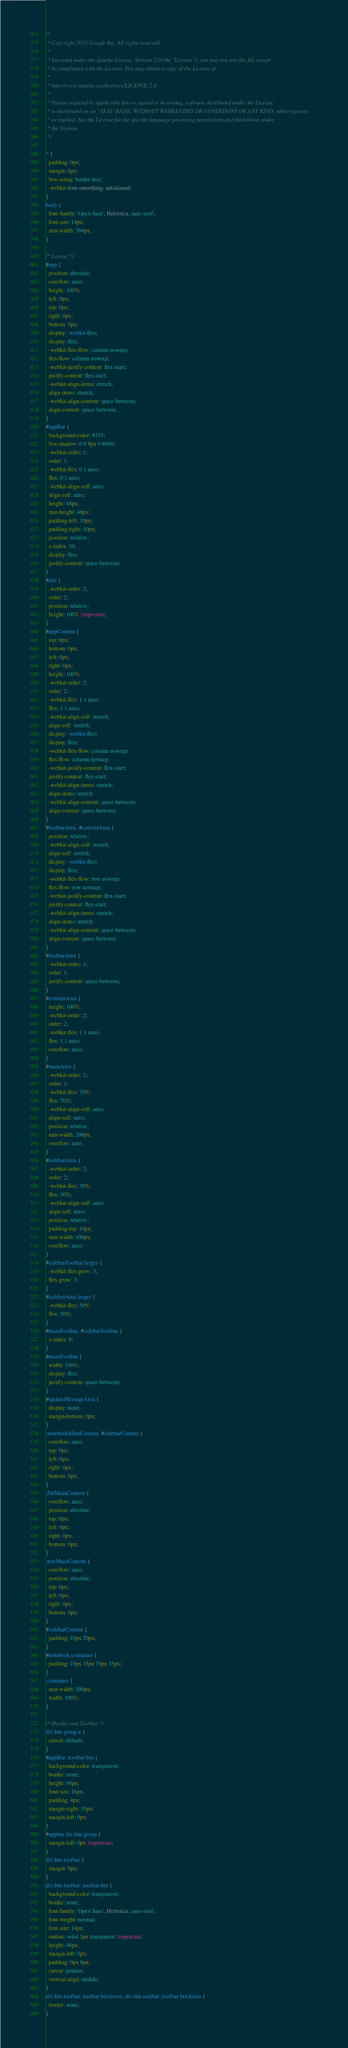<code> <loc_0><loc_0><loc_500><loc_500><_CSS_>/*
 * Copyright 2015 Google Inc. All rights reserved.
 *
 * Licensed under the Apache License, Version 2.0 (the "License"); you may not use this file except
 * in compliance with the License. You may obtain a copy of the License at
 *
 * http://www.apache.org/licenses/LICENSE-2.0
 *
 * Unless required by applicable law or agreed to in writing, software distributed under the License
 * is distributed on an "AS IS" BASIS, WITHOUT WARRANTIES OR CONDITIONS OF ANY KIND, either express
 * or implied. See the License for the specific language governing permissions and limitations under
 * the License.
 */

* {
  padding: 0px;
  margin: 0px;
  box-sizing: border-box;
  -webkit-font-smoothing: antialiased;
}
body {
  font-family: 'Open Sans', Helvetica, sans-serif;
  font-size: 14px;
  min-width: 760px;
}

/* Layout */
#app {
  position: absolute;
  overflow: auto;
  height: 100%;
  left: 0px;
  top: 0px;
  right: 0px;
  bottom: 0px;
  display: -webkit-flex;
  display: flex;
  -webkit-flex-flow: column nowrap;
  flex-flow: column nowrap;
  -webkit-justify-content: flex-start;
  justify-content: flex-start;
  -webkit-align-items: stretch;
  align-items: stretch;
  -webkit-align-content: space-between;
  align-content: space-between;
}
#appBar {
  background-color: #333;
  box-shadow: 0 0 8px 0 #000;
  -webkit-order: 1;
  order: 1;
  -webkit-flex: 0 1 auto;
  flex: 0 1 auto;
  -webkit-align-self: auto;
  align-self: auto;
  height: 48px;
  min-height: 48px;
  padding-left: 10px;
  padding-right: 10px;
  position: relative;
  z-index: 10;
  display: flex;
  justify-content: space-between;
}
#site {
  -webkit-order: 2;
  order: 2;
  position: relative;
  height: 100% !important;
}
#appContent {
  top: 0px;
  bottom: 0px;
  left: 0px;
  right: 0px;
  height: 100%;
  -webkit-order: 2;
  order: 2;
  -webkit-flex: 1 1 auto;
  flex: 1 1 auto;
  -webkit-align-self: stretch;
  align-self: stretch;
  display: -webkit-flex;
  display: flex;
  -webkit-flex-flow: column nowrap;
  flex-flow: column nowrap;
  -webkit-justify-content: flex-start;
  justify-content: flex-start;
  -webkit-align-items: stretch;
  align-items: stretch;
  -webkit-align-content: space-between;
  align-content: space-between;
}
#toolbarArea, #contentArea {
  position: relative;
  -webkit-align-self: stretch;
  align-self: stretch;
  display: -webkit-flex;
  display: flex;
  -webkit-flex-flow: row nowrap;
  flex-flow: row nowrap;
  -webkit-justify-content: flex-start;
  justify-content: flex-start;
  -webkit-align-items: stretch;
  align-items: stretch;
  -webkit-align-content: space-between;
  align-content: space-between;
}
#toolbarArea {
  -webkit-order: 1;
  order: 1;
  justify-content: space-between;
}
#contentArea {
  height: 100%;
  -webkit-order: 2;
  order: 2;
  -webkit-flex: 1 1 auto;
  flex: 1 1 auto;
  overflow: auto;
}
#mainArea {
  -webkit-order: 1;
  order: 1;
  -webkit-flex: 70%;
  flex: 70%;
  -webkit-align-self: auto;
  align-self: auto;
  position: relative;
  min-width: 200px;
  overflow: auto;
}
#sidebarArea {
  -webkit-order: 2;
  order: 2;
  -webkit-flex: 30%;
  flex: 30%;
  -webkit-align-self: auto;
  align-self: auto;
  position: relative;
  padding-top: 10px;
  min-width: 100px;
  overflow: auto;
}
#sidebarToolbar.larger {
  -webkit-flex-grow: 3;
  flex-grow: 3;
}
#sidebarArea.larger {
  -webkit-flex: 50%;
  flex: 50%;
}
#mainToolbar, #sidebarToolbar {
  z-index: 8;
}
#mainToolbar {
  width: 100%;
  display: flex;
  justify-content: space-between;
}
#updateMessageArea {
  display: none;
  margin-bottom: 0px;
}
.notebookMainContent, #sidebarContent {
  overflow: auto;
  top: 0px;
  left: 0px;
  right: 0px;
  bottom: 0px;
}
.fileMainContent {
  overflow: auto;
  position: absolute;
  top: 0px;
  left: 0px;
  right: 0px;
  bottom: 0px;
}
.treeMainContent {
  overflow: auto;
  position: absolute;
  top: 0px;
  left: 0px;
  right: 0px;
  bottom: 0px;
}
#sidebarContent {
  padding: 10px 20px;
}
#notebook-container {
  padding: 10px 35px 70px 35px;
}
.container {
  min-width: 200px;
  width: 100%;
}

/* Header and Toolbar */
div.btn-group a {
  cursor: default;
}
#appBar .toolbar-btn {
  background-color: transparent;
  border: none;
  height: 48px;
  font-size: 16px;
  padding: 4px;
  margin-right: 10px;
  margin-left: 0px;
}
#appbar div.btn-group {
  margin-left: 0px !important;
}
div.btn-toolbar {
  margin: 0px;
}
div.btn-toolbar .toolbar-btn {
  background-color: transparent;
  border: none;
  font-family: 'Open Sans', Helvetica, sans-serif;
  font-weight: normal;
  font-size: 14px;
  outline: solid 1px transparent !important;
  height: 46px;
  margin-left: 0px;
  padding: 0px 8px;
  cursor: pointer;
  vertical-align: middle;
}
div.btn-toolbar .toolbar-btn:hover, div.btn-toolbar .toolbar-btn:focus {
  border: none;
}</code> 